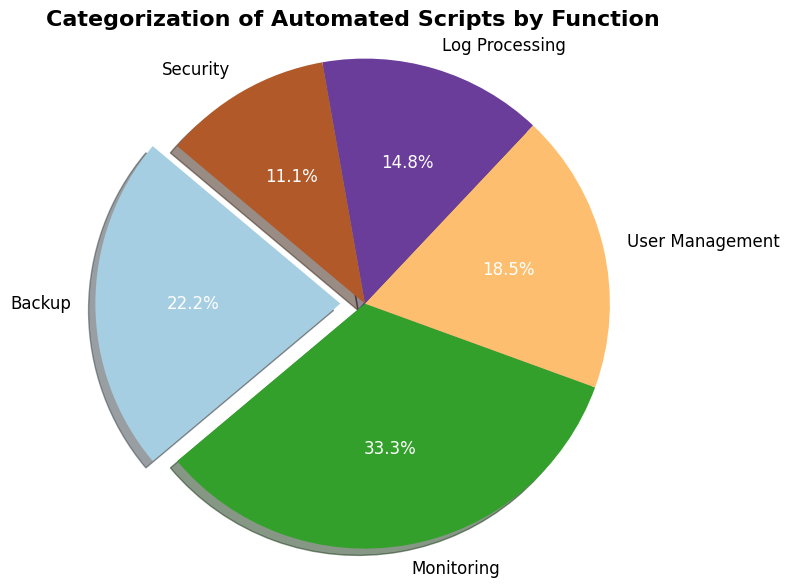Which category of scripts occupies the largest proportion of the total? By looking at the pie chart, the largest wedge represents Monitoring with its size noticeably larger than the other categories. This category occupies the largest proportion of the total.
Answer: Monitoring Which category of scripts occupies the smallest proportion of the total? By looking at the pie chart, the smallest wedge represents Security, which is significantly smaller than the other categories.
Answer: Security How many percentage points more is the proportion of Monitoring scripts compared to User Management scripts? The chart shows the percentage for each category: Monitoring is 37.5% and User Management is 20.8%. The difference is 37.5% - 20.8% = 16.7%.
Answer: 16.7% Is the proportion of Backup scripts greater than the proportion of Log Processing scripts? From the pie chart, the Backup wedge shows 25%, while the Log Processing wedge shows 16.7%. Thus, Backup's proportion is greater than Log Processing's.
Answer: Yes What is the sum of the proportions for Backup and Security scripts? The pie chart shows the percentages for Backup and Security as 25% and 12.5% respectively. Adding these together, 25% + 12.5% = 37.5%.
Answer: 37.5% Which categories combined make up exactly 50% of the total scripts? By examining the pie chart, User Management (20.8%) and Log Processing (16.7%) add up to 37.5%, while Backup (25%) and Security (12.5%) sum to 37.5% as well. Monitoring (37.5%) alone is also 37.5%. Adding Security (12.5%) to Monitoring (37.5%) gives 50%.
Answer: Monitoring, Security Of the pies represented in cool colors, which one has the highest percentage? Assuming cool colors might be represented by blue tones used in standard palettes, the pie chart needs to be examined for such hues. Suppose Log Processing is the coolest color used here and the percentage associated with it is 16.7%.
Answer: Log Processing Which categories of scripts have a percentage less than 20%? From the pie chart, both Log Processing (16.7%) and Security (12.5%) have percentages less than 20%.
Answer: Log Processing, Security 